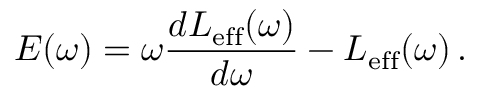Convert formula to latex. <formula><loc_0><loc_0><loc_500><loc_500>E ( \omega ) = \omega \frac { d L _ { e f f } ( \omega ) } { d \omega } - L _ { e f f } ( \omega ) \, .</formula> 